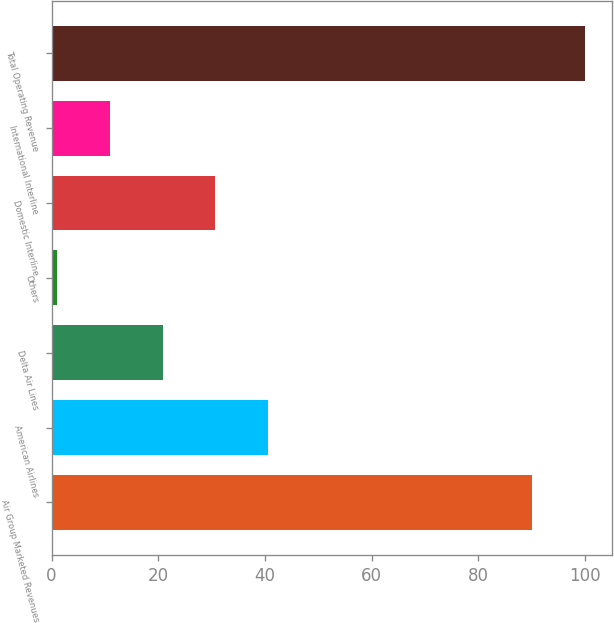<chart> <loc_0><loc_0><loc_500><loc_500><bar_chart><fcel>Air Group Marketed Revenues<fcel>American Airlines<fcel>Delta Air Lines<fcel>Others<fcel>Domestic Interline<fcel>International Interline<fcel>Total Operating Revenue<nl><fcel>90<fcel>40.6<fcel>20.8<fcel>1<fcel>30.7<fcel>10.9<fcel>100<nl></chart> 